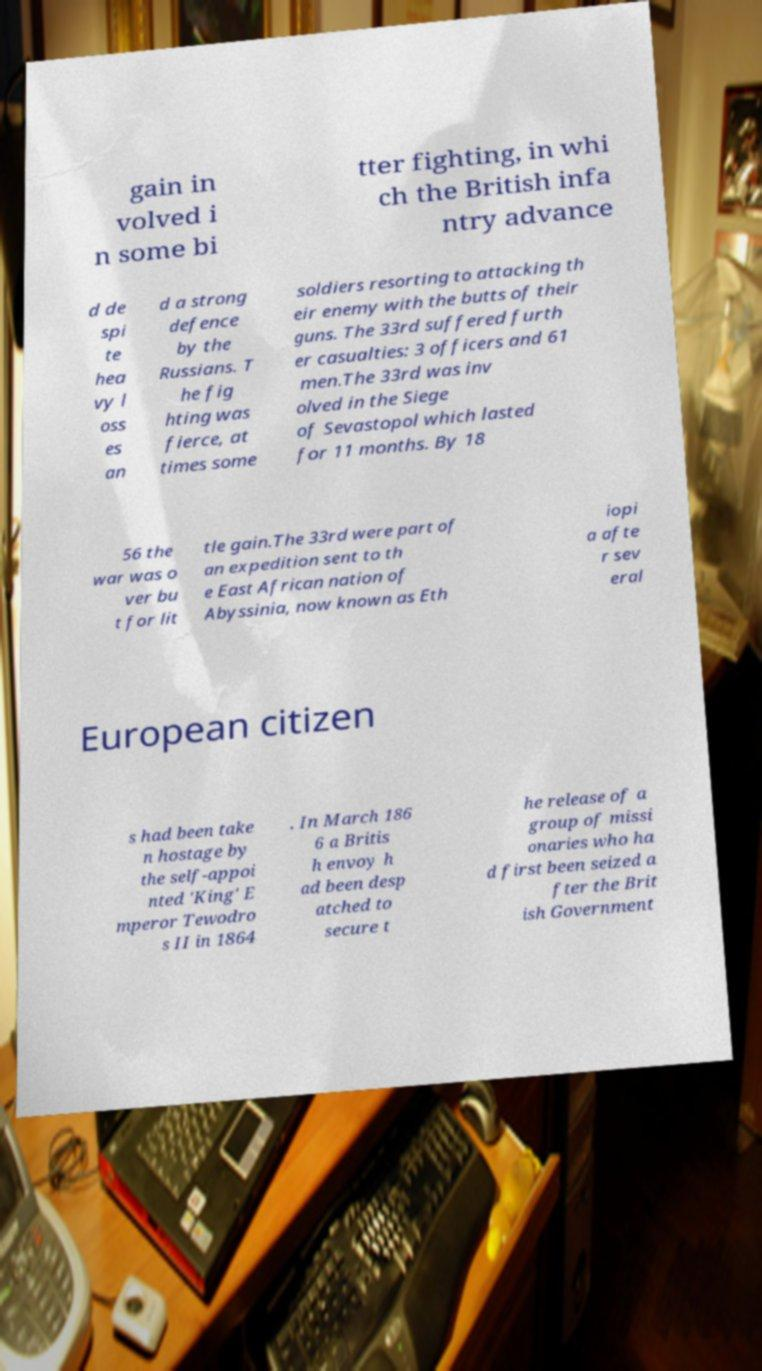I need the written content from this picture converted into text. Can you do that? gain in volved i n some bi tter fighting, in whi ch the British infa ntry advance d de spi te hea vy l oss es an d a strong defence by the Russians. T he fig hting was fierce, at times some soldiers resorting to attacking th eir enemy with the butts of their guns. The 33rd suffered furth er casualties: 3 officers and 61 men.The 33rd was inv olved in the Siege of Sevastopol which lasted for 11 months. By 18 56 the war was o ver bu t for lit tle gain.The 33rd were part of an expedition sent to th e East African nation of Abyssinia, now known as Eth iopi a afte r sev eral European citizen s had been take n hostage by the self-appoi nted 'King' E mperor Tewodro s II in 1864 . In March 186 6 a Britis h envoy h ad been desp atched to secure t he release of a group of missi onaries who ha d first been seized a fter the Brit ish Government 